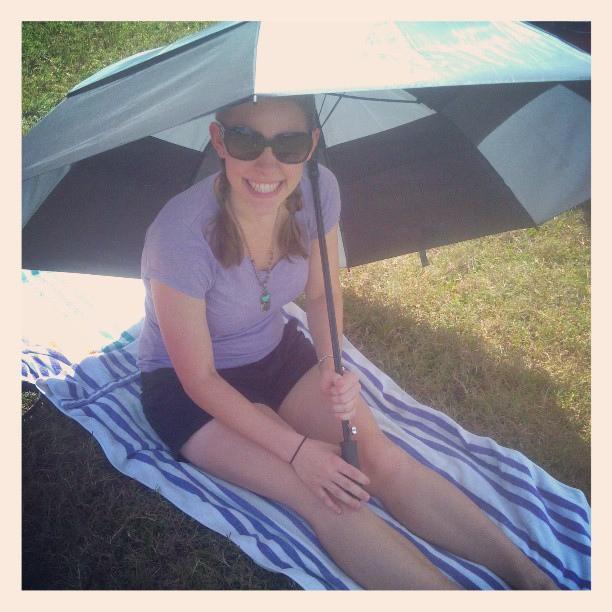How many horses are there?
Give a very brief answer. 0. 